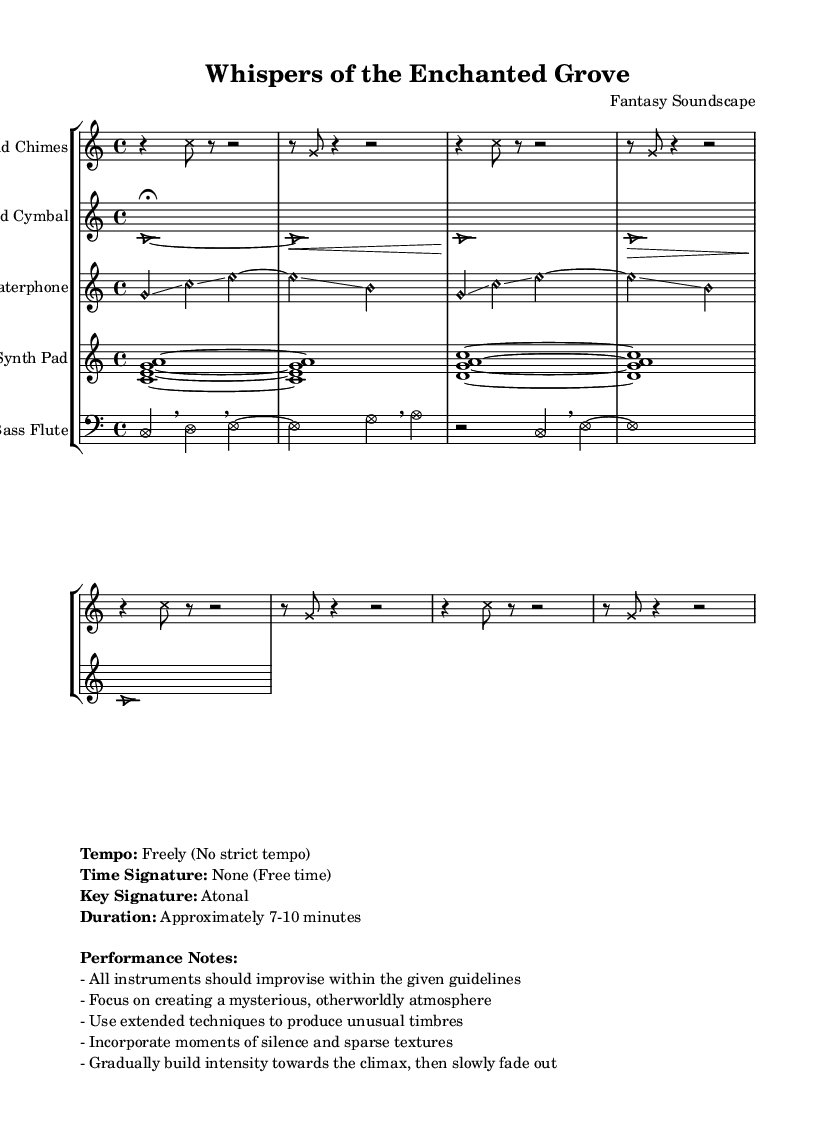What is the tempo of this music? The tempo is specified as "Freely (No strict tempo)," indicating that the performance can vary in speed without a strict tempo guideline.
Answer: Freely (No strict tempo) What is the time signature of this piece? The time signature is stated as "None (Free time)," which means that there is no specific meter and performers can take liberties with how they organize the music's rhythm.
Answer: None (Free time) What is the key signature of this composition? The key signature is noted as "Atonal," which indicates that the music does not adhere to a traditional key signature with sharps or flats, allowing for a freedom in pitch.
Answer: Atonal What is the duration of the performance? The duration is described as "Approximately 7-10 minutes," suggesting that the piece should be performed within this time range.
Answer: Approximately 7-10 minutes Which instrument has a note head style of "harmonic"? The "Waterphone" section features the note head style of "harmonic," as indicated in the notation where the note heads are marked accordingly.
Answer: Waterphone Why might moments of silence be important in this piece? Moments of silence are important as they contribute to creating a mysterious, otherworldly atmosphere, allowing tension to build and maintaining the focus of the performance on the evolving soundscape.
Answer: To create mystery How does the "Bowed Cymbal" contribute to the overall mood of the composition? The "Bowed Cymbal" has a consistent sustained sound produced with dynamics that vary (indicated by the crescendos and decrescendos), which enhances the ethereal quality of the music and deepens the immersive experience.
Answer: Ethereal quality 